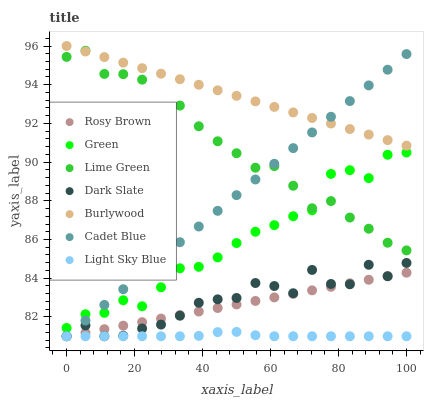Does Light Sky Blue have the minimum area under the curve?
Answer yes or no. Yes. Does Burlywood have the maximum area under the curve?
Answer yes or no. Yes. Does Rosy Brown have the minimum area under the curve?
Answer yes or no. No. Does Rosy Brown have the maximum area under the curve?
Answer yes or no. No. Is Cadet Blue the smoothest?
Answer yes or no. Yes. Is Lime Green the roughest?
Answer yes or no. Yes. Is Burlywood the smoothest?
Answer yes or no. No. Is Burlywood the roughest?
Answer yes or no. No. Does Cadet Blue have the lowest value?
Answer yes or no. Yes. Does Burlywood have the lowest value?
Answer yes or no. No. Does Burlywood have the highest value?
Answer yes or no. Yes. Does Rosy Brown have the highest value?
Answer yes or no. No. Is Light Sky Blue less than Green?
Answer yes or no. Yes. Is Burlywood greater than Dark Slate?
Answer yes or no. Yes. Does Lime Green intersect Burlywood?
Answer yes or no. Yes. Is Lime Green less than Burlywood?
Answer yes or no. No. Is Lime Green greater than Burlywood?
Answer yes or no. No. Does Light Sky Blue intersect Green?
Answer yes or no. No. 